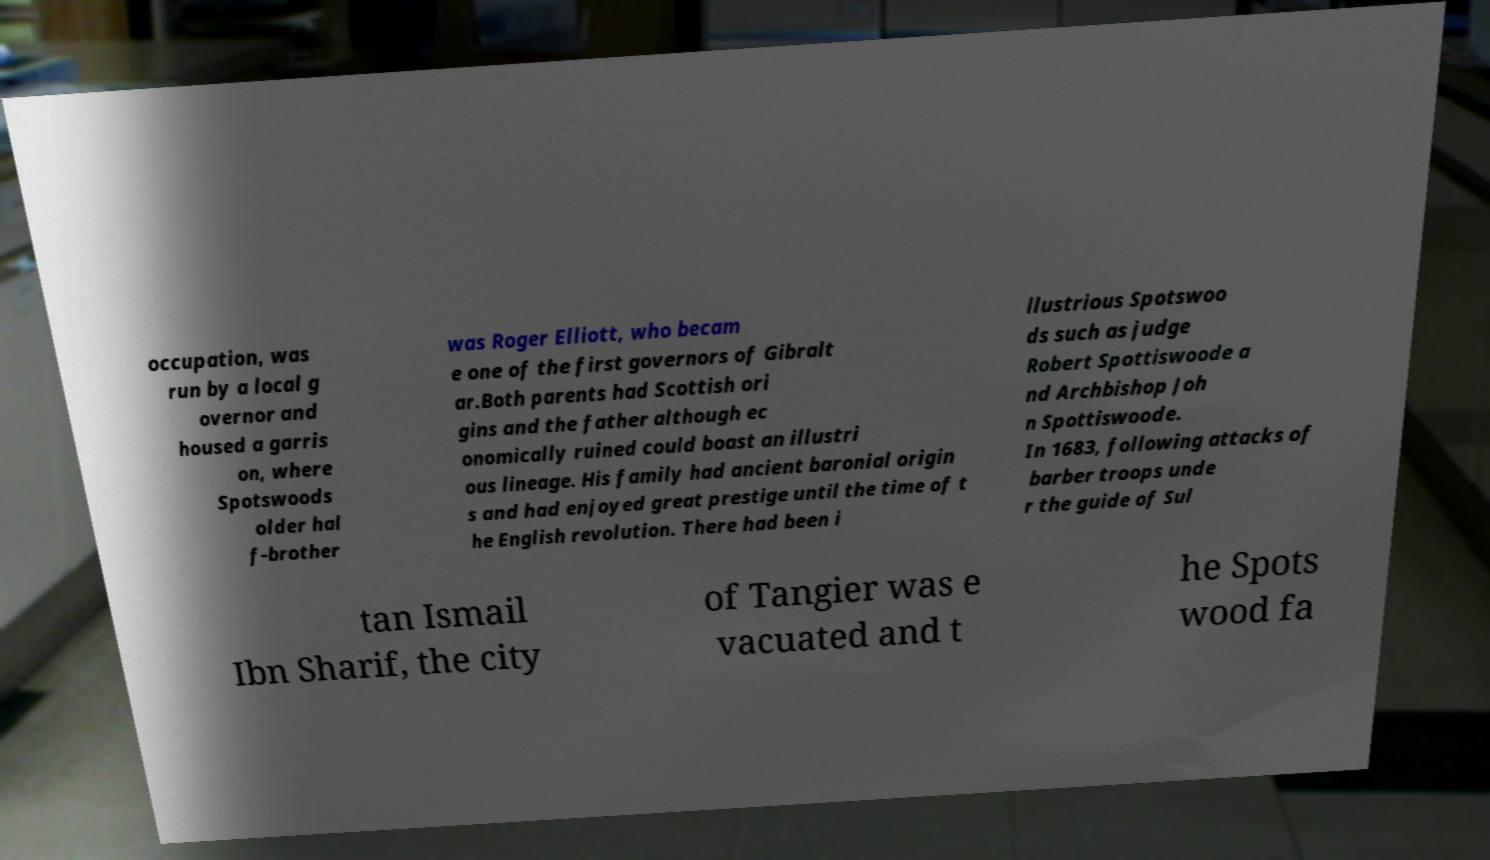Please identify and transcribe the text found in this image. occupation, was run by a local g overnor and housed a garris on, where Spotswoods older hal f-brother was Roger Elliott, who becam e one of the first governors of Gibralt ar.Both parents had Scottish ori gins and the father although ec onomically ruined could boast an illustri ous lineage. His family had ancient baronial origin s and had enjoyed great prestige until the time of t he English revolution. There had been i llustrious Spotswoo ds such as judge Robert Spottiswoode a nd Archbishop Joh n Spottiswoode. In 1683, following attacks of barber troops unde r the guide of Sul tan Ismail Ibn Sharif, the city of Tangier was e vacuated and t he Spots wood fa 